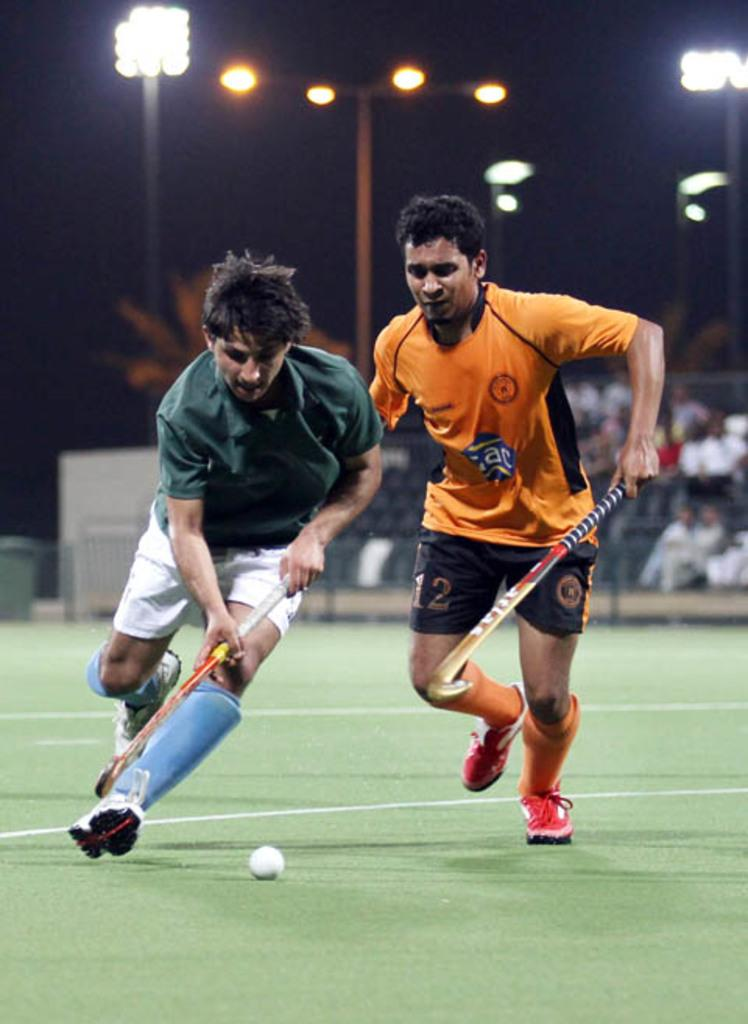<image>
Summarize the visual content of the image. A man playing field hockey with an orange shirt on and the number 12 on his shorts is trying to steal the ball. 